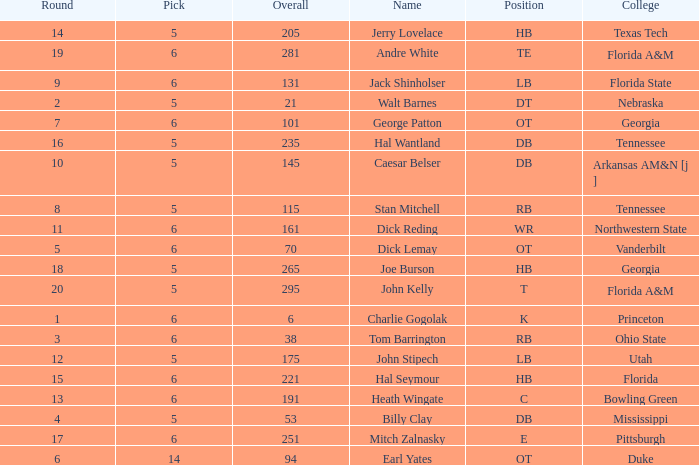What is the highest Pick, when Round is greater than 15, and when College is "Tennessee"? 5.0. 